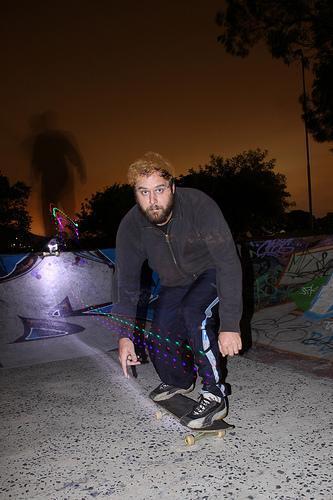How many people are shown?
Give a very brief answer. 1. 